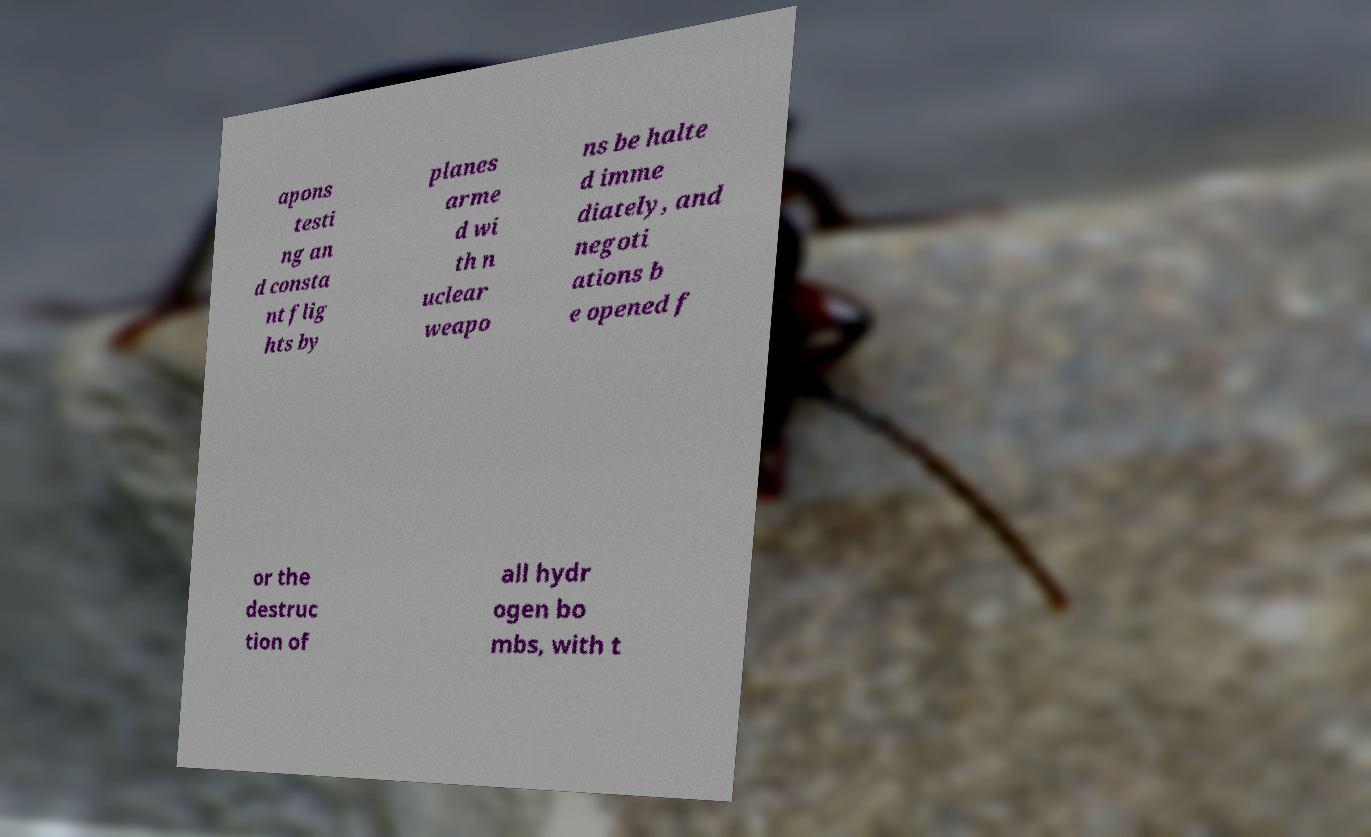Please read and relay the text visible in this image. What does it say? apons testi ng an d consta nt flig hts by planes arme d wi th n uclear weapo ns be halte d imme diately, and negoti ations b e opened f or the destruc tion of all hydr ogen bo mbs, with t 